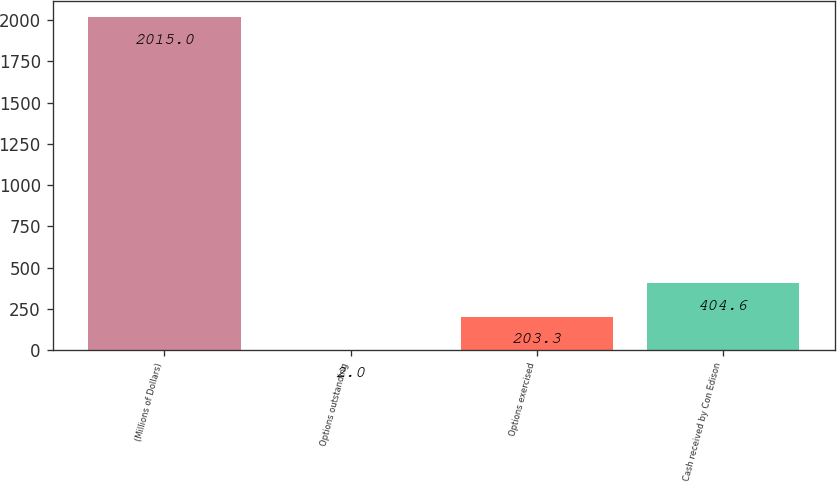Convert chart. <chart><loc_0><loc_0><loc_500><loc_500><bar_chart><fcel>(Millions of Dollars)<fcel>Options outstanding<fcel>Options exercised<fcel>Cash received by Con Edison<nl><fcel>2015<fcel>2<fcel>203.3<fcel>404.6<nl></chart> 